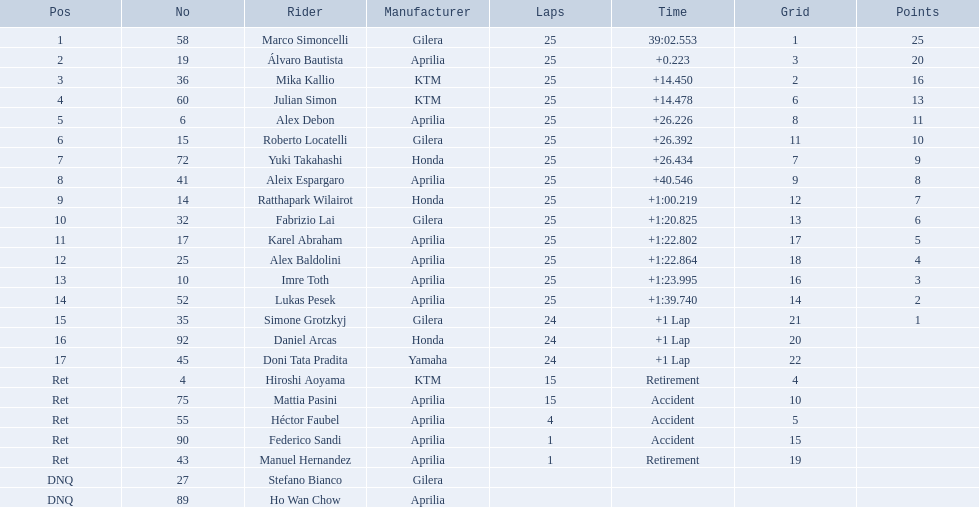Who are all the riders? Marco Simoncelli, Álvaro Bautista, Mika Kallio, Julian Simon, Alex Debon, Roberto Locatelli, Yuki Takahashi, Aleix Espargaro, Ratthapark Wilairot, Fabrizio Lai, Karel Abraham, Alex Baldolini, Imre Toth, Lukas Pesek, Simone Grotzkyj, Daniel Arcas, Doni Tata Pradita, Hiroshi Aoyama, Mattia Pasini, Héctor Faubel, Federico Sandi, Manuel Hernandez, Stefano Bianco, Ho Wan Chow. Which held rank 1? Marco Simoncelli. What was the quickest overall duration? 39:02.553. Who does this duration belong to? Marco Simoncelli. 